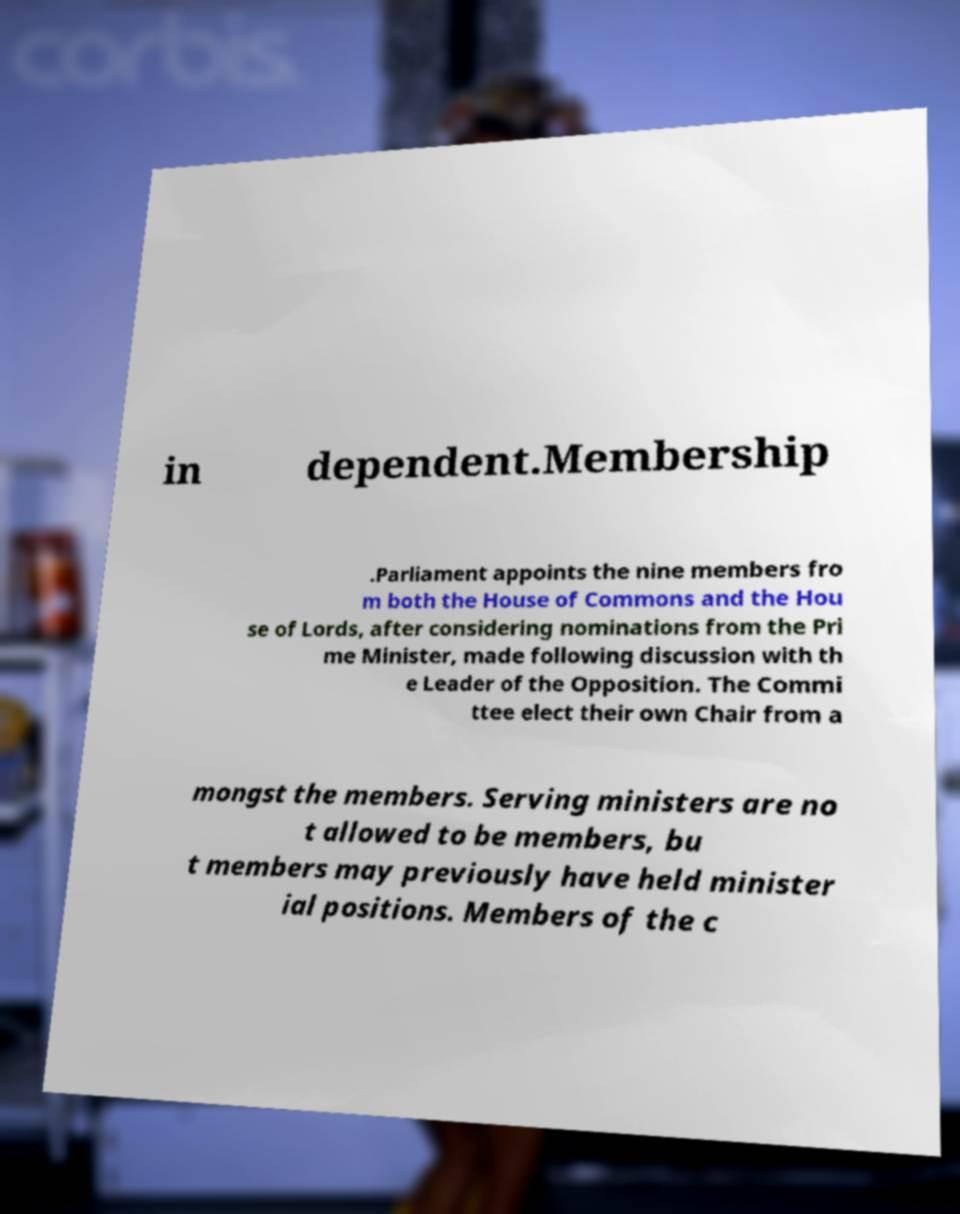There's text embedded in this image that I need extracted. Can you transcribe it verbatim? in dependent.Membership .Parliament appoints the nine members fro m both the House of Commons and the Hou se of Lords, after considering nominations from the Pri me Minister, made following discussion with th e Leader of the Opposition. The Commi ttee elect their own Chair from a mongst the members. Serving ministers are no t allowed to be members, bu t members may previously have held minister ial positions. Members of the c 